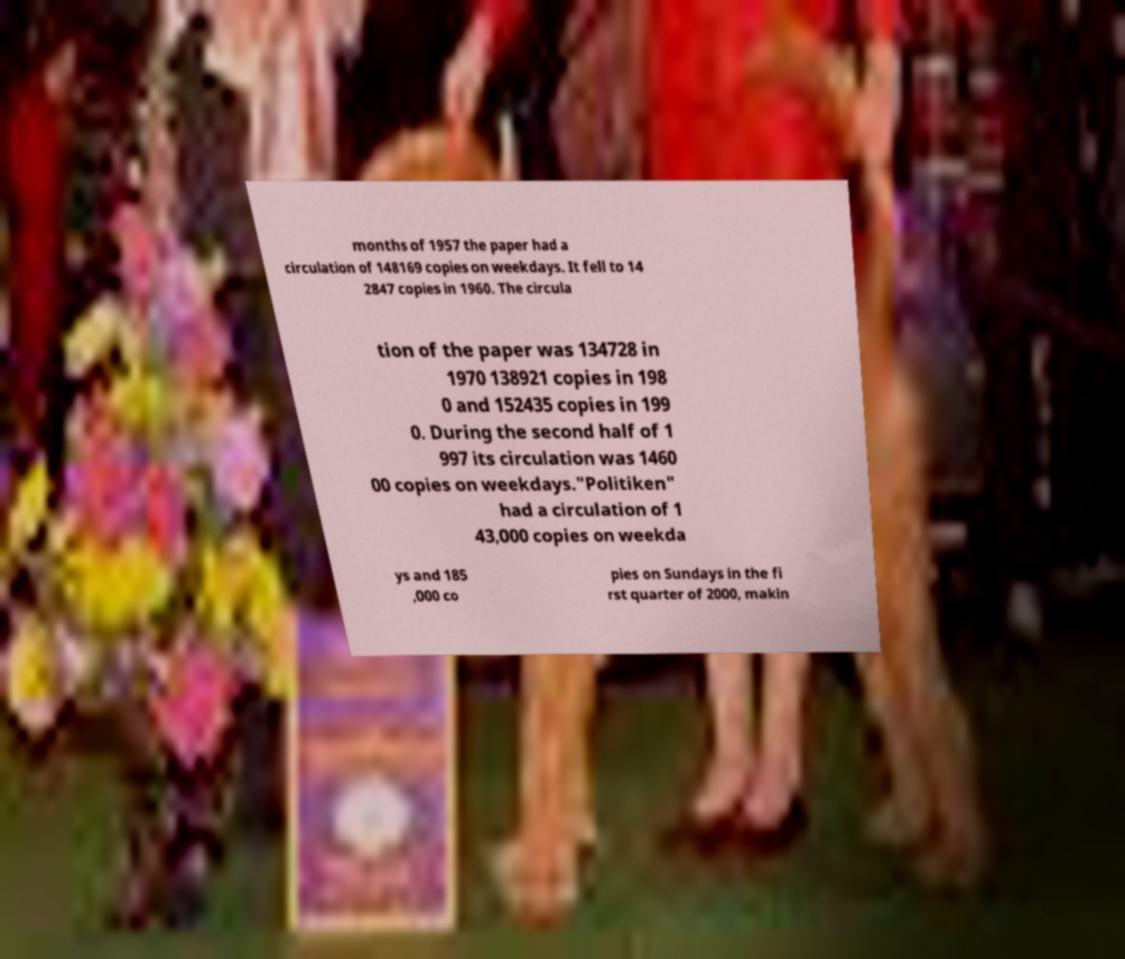Can you read and provide the text displayed in the image?This photo seems to have some interesting text. Can you extract and type it out for me? months of 1957 the paper had a circulation of 148169 copies on weekdays. It fell to 14 2847 copies in 1960. The circula tion of the paper was 134728 in 1970 138921 copies in 198 0 and 152435 copies in 199 0. During the second half of 1 997 its circulation was 1460 00 copies on weekdays."Politiken" had a circulation of 1 43,000 copies on weekda ys and 185 ,000 co pies on Sundays in the fi rst quarter of 2000, makin 